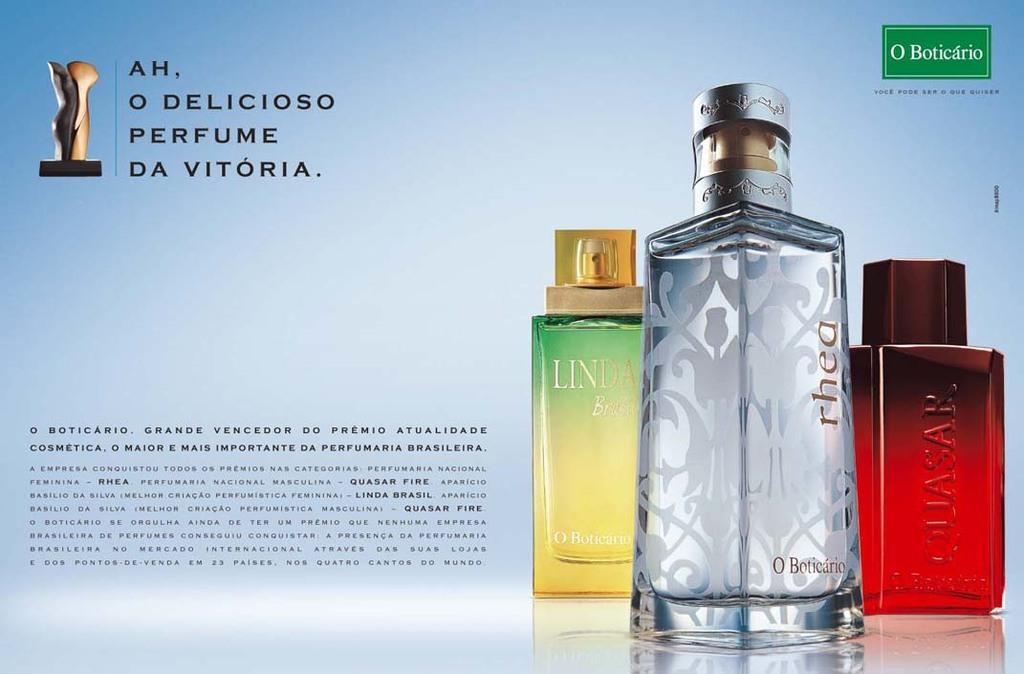<image>
Give a short and clear explanation of the subsequent image. An ad for Rhea perfume is displayed in a magazine. 